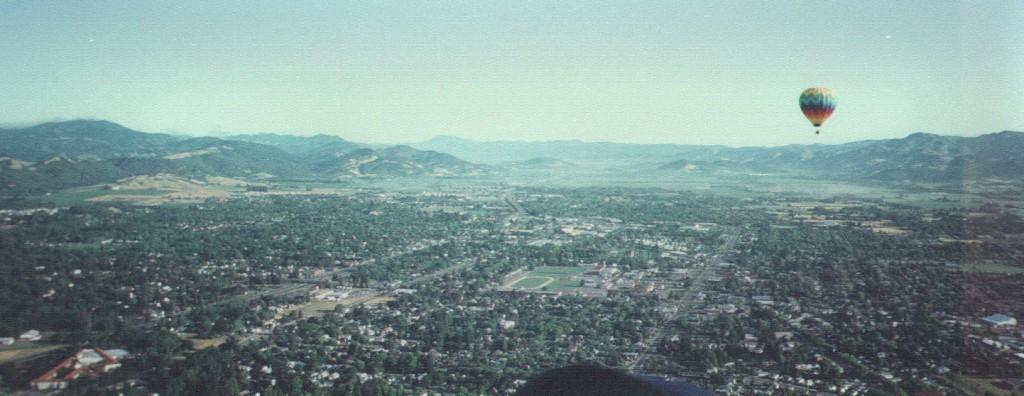What type of natural landscape can be seen in the background of the image? There are mountains in the background of the image. What is the main mode of transportation in the image? There is an air balloon in the image. What type of vegetation is present in the image? There are trees in the image. What type of man-made structures can be seen in the image? There are buildings in the image. What is visible at the top of the image? The sky is visible at the top of the image. What type of cap is the air balloon wearing in the image? There is no cap present in the image, as air balloons do not wear caps. What type of prose can be seen written on the mountains in the image? There is no prose present on the mountains in the image; they are a natural landscape. 